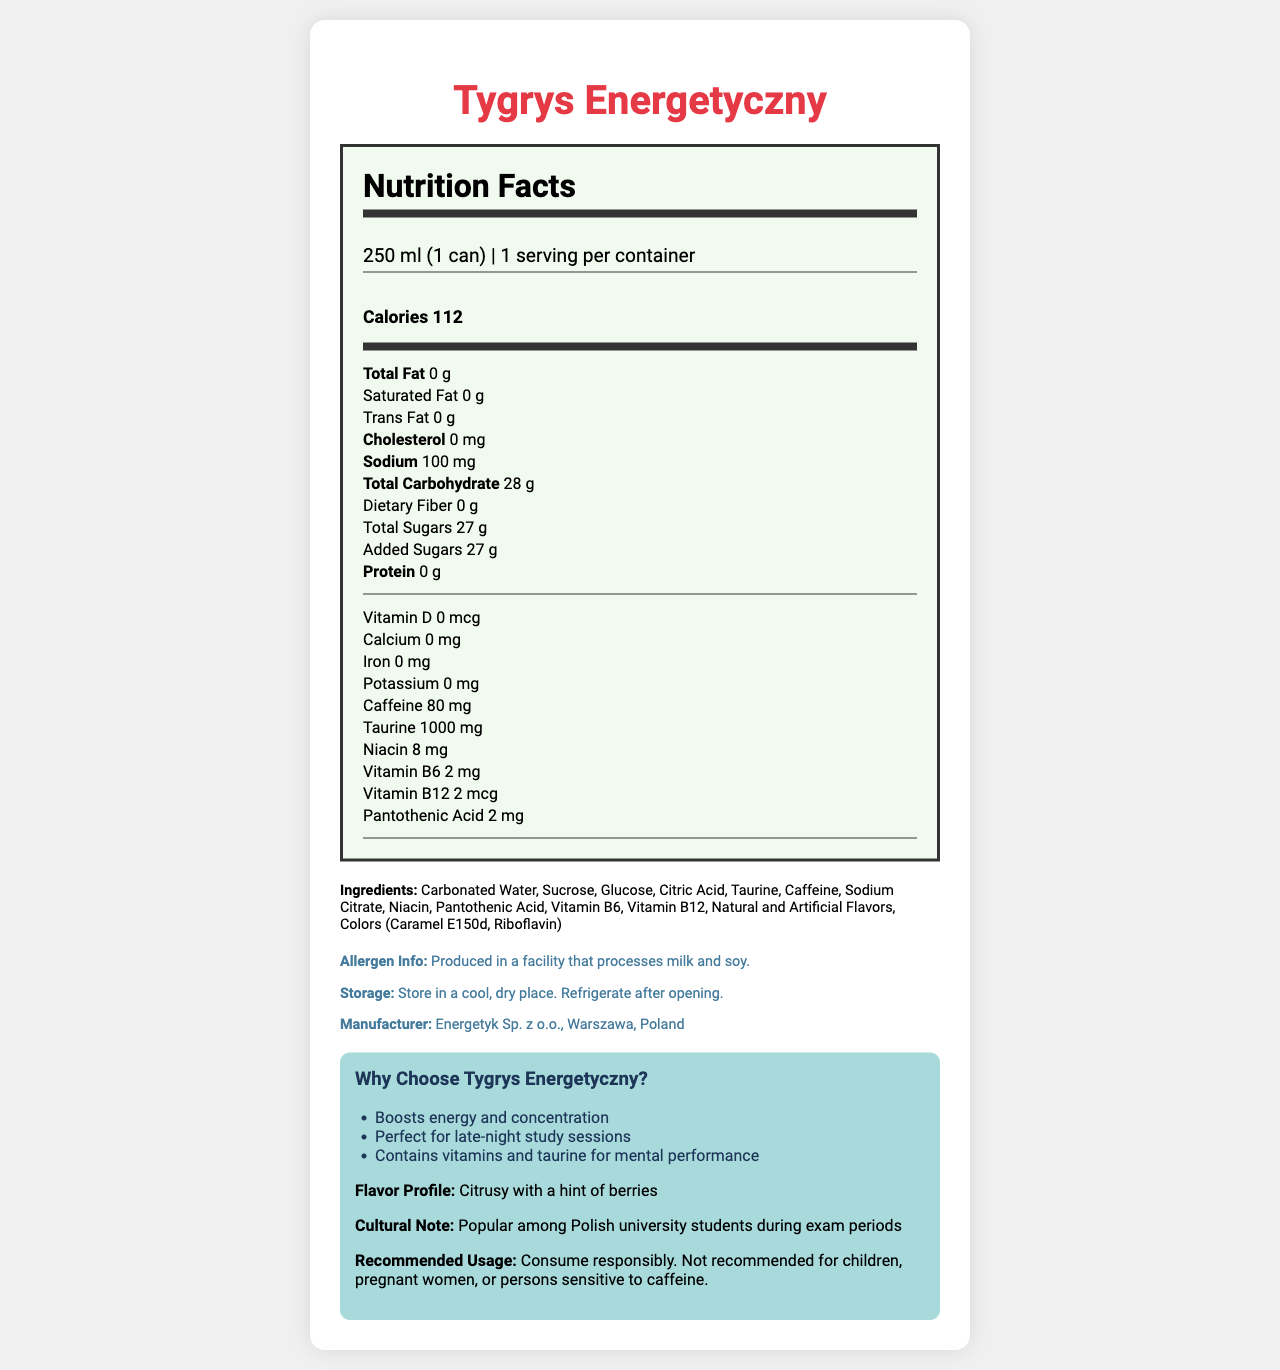what is the serving size of Tygrys Energetyczny? The serving size is mentioned directly under the product name and on the document as "250 ml (1 can)".
Answer: 250 ml (1 can) How many servings per container are there? The document clearly states there is 1 serving per container.
Answer: 1 How many calories does Tygrys Energetyczny contain per serving? The calories per serving are explicitly listed in the main nutrients section as "Calories 112".
Answer: 112 What is the amount of caffeine per serving? The nutrition facts show the caffeine content listed as "Caffeine 80 mg".
Answer: 80 mg What are the main ingredients of Tygrys Energetyczny? The document lists the ingredients under the “Ingredients” section.
Answer: Carbonated Water, Sucrose, Glucose, Citric Acid, Taurine, Caffeine, Sodium Citrate, Niacin, Pantothenic Acid, Vitamin B6, Vitamin B12, Natural and Artificial Flavors, Colors (Caramel E150d, Riboflavin) Which nutrient is present in the highest amount: sodium, protein, or taurine? The taurine content is 1000 mg, which is significantly higher compared to sodium (100 mg) and protein (0 g).
Answer: Taurine What is the total carbohydrate content per serving? A. 10 g B. 20 g C. 28 g D. 30 g The total carbohydrate content is listed in the document as "28 g".
Answer: C. 28 g Which vitamin is present in an amount of 8 mg? 1. Vitamin D 2. Niacin 3. Vitamin B6 As per the document, Niacin is listed with a content of "8 mg”.
Answer: 2. Niacin This product claims to boost energy and concentration. True or False? The marketing claims section includes "Boosts energy and concentration".
Answer: True Briefly describe the main idea of the document. The document revolves around the detailed nutritional facts, ingredients, and marketing claims of Tygrys Energetyczny, giving a comprehensive view of its nutritional profile and recommended usage.
Answer: This document provides detailed nutritional information about the Polish energy drink Tygrys Energetyczny. It includes serving size, calories, and the amount of various nutrients and vitamins per serving. It also lists ingredients and highlights marketing claims that emphasize its benefits like boosting energy and concentration. Additionally, it provides information about manufacturing and storage. What is the address of the manufacturer? The document only mentions "Energetyk Sp. z o.o., Warszawa, Poland" as the manufacturer but does not provide a specific street address.
Answer: Not enough information 